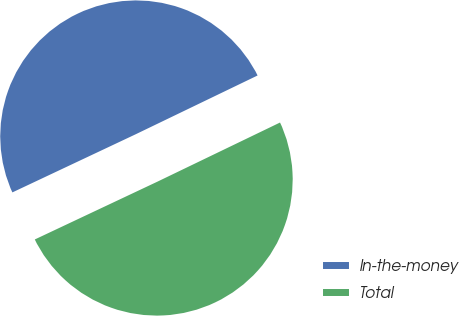<chart> <loc_0><loc_0><loc_500><loc_500><pie_chart><fcel>In-the-money<fcel>Total<nl><fcel>49.86%<fcel>50.14%<nl></chart> 